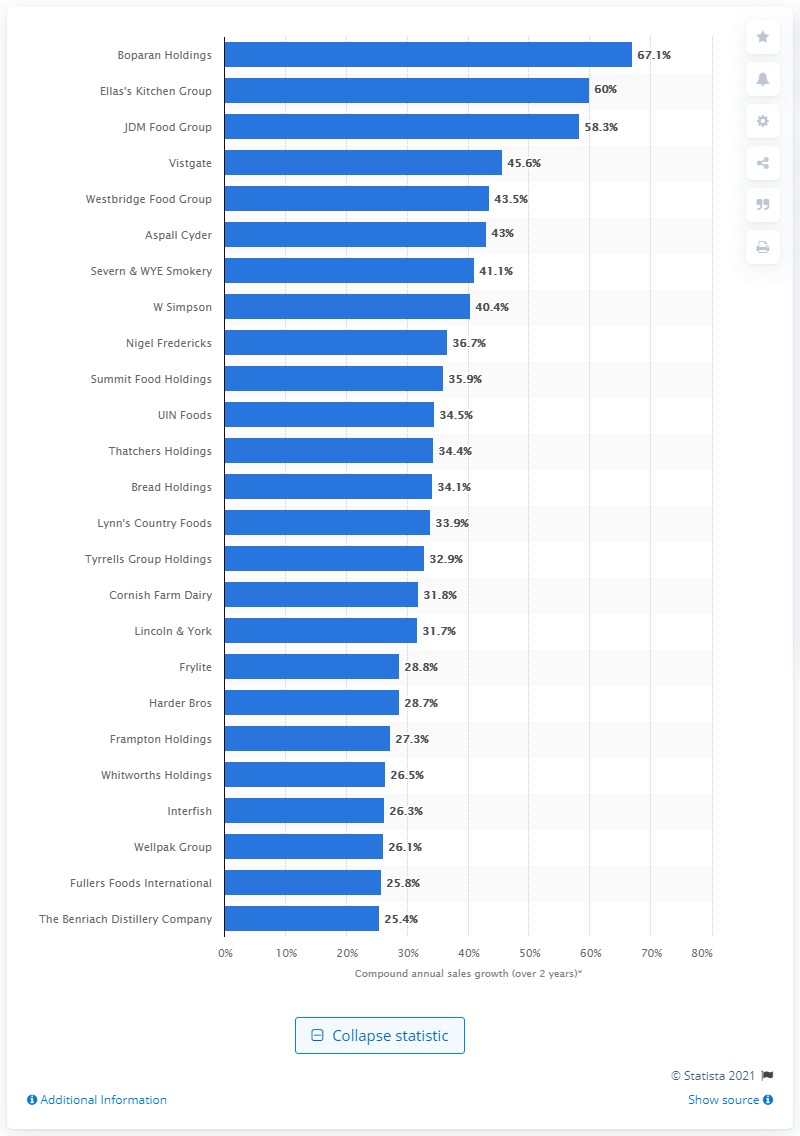Outline some significant characteristics in this image. It is Boparan Holdings that ranked highest, with a compound annual sales growth of 67.1 percent over the past two years. 